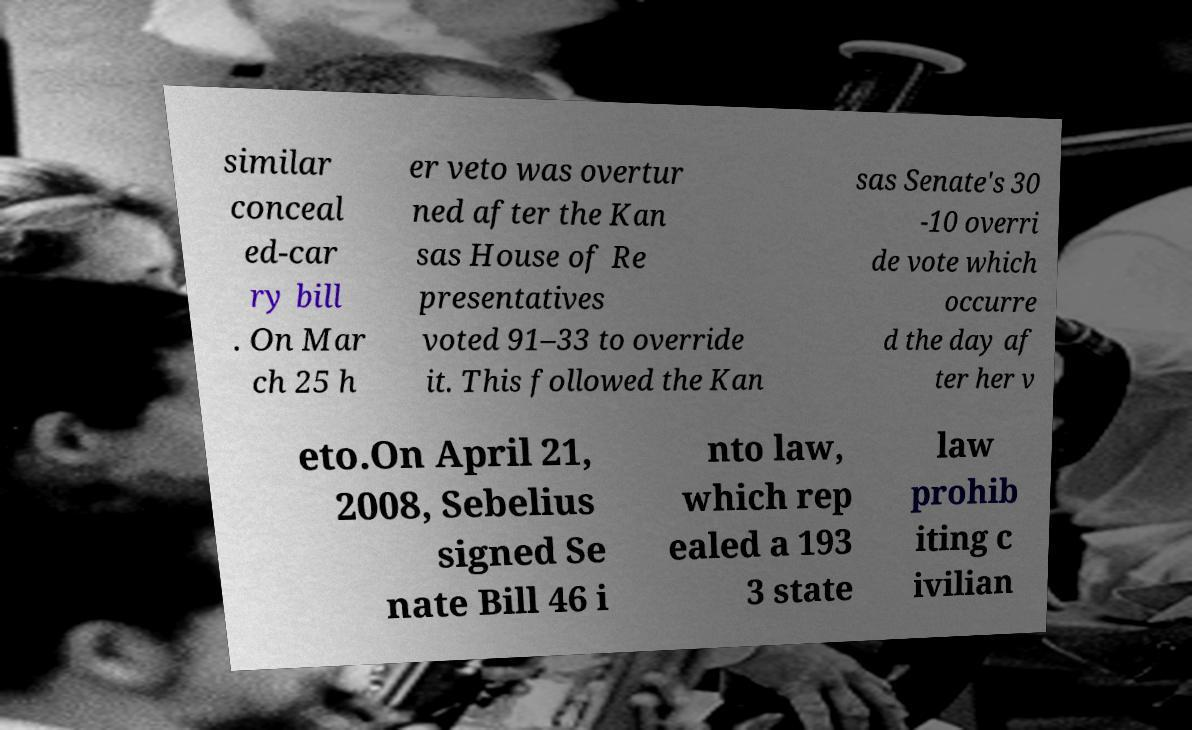I need the written content from this picture converted into text. Can you do that? similar conceal ed-car ry bill . On Mar ch 25 h er veto was overtur ned after the Kan sas House of Re presentatives voted 91–33 to override it. This followed the Kan sas Senate's 30 -10 overri de vote which occurre d the day af ter her v eto.On April 21, 2008, Sebelius signed Se nate Bill 46 i nto law, which rep ealed a 193 3 state law prohib iting c ivilian 